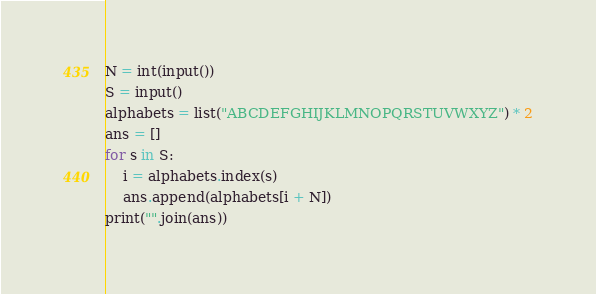Convert code to text. <code><loc_0><loc_0><loc_500><loc_500><_Python_>N = int(input())
S = input()
alphabets = list("ABCDEFGHIJKLMNOPQRSTUVWXYZ") * 2
ans = []
for s in S:
    i = alphabets.index(s)
    ans.append(alphabets[i + N])
print("".join(ans))</code> 